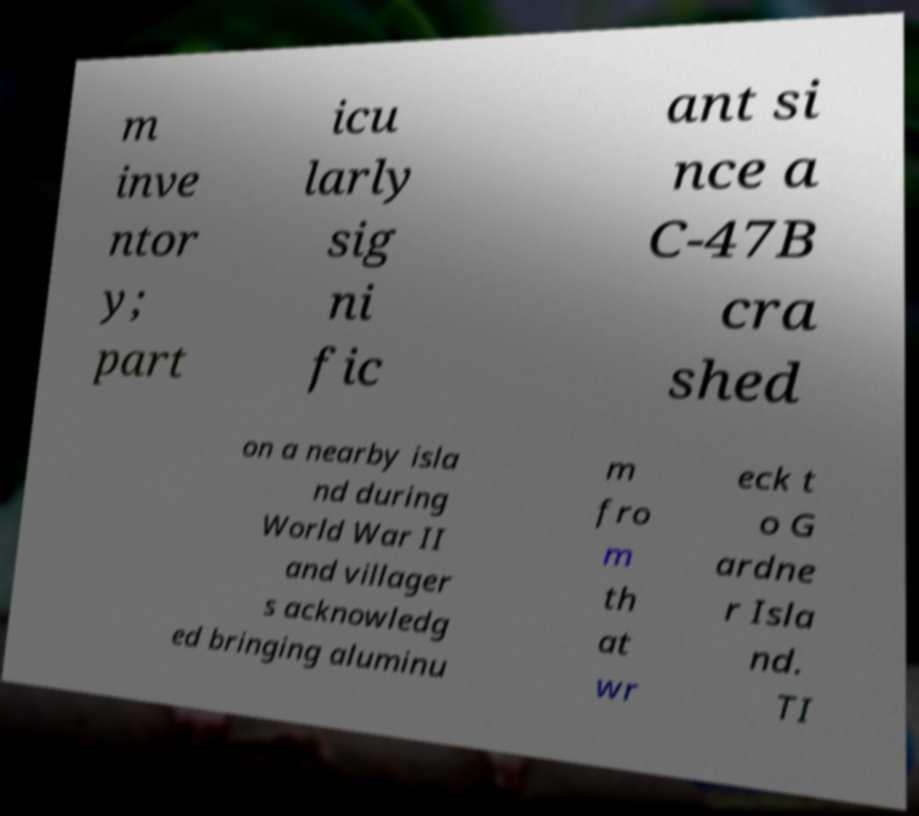For documentation purposes, I need the text within this image transcribed. Could you provide that? m inve ntor y; part icu larly sig ni fic ant si nce a C-47B cra shed on a nearby isla nd during World War II and villager s acknowledg ed bringing aluminu m fro m th at wr eck t o G ardne r Isla nd. TI 